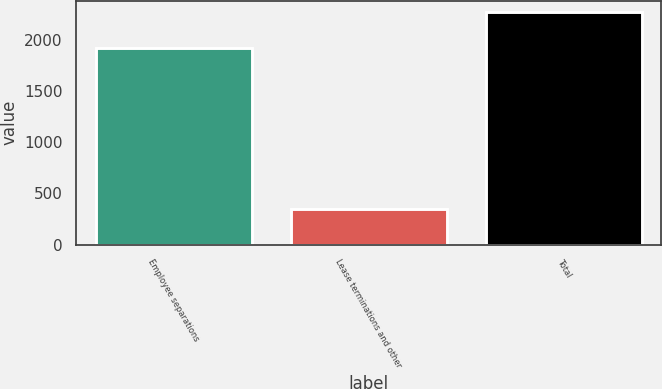Convert chart. <chart><loc_0><loc_0><loc_500><loc_500><bar_chart><fcel>Employee separations<fcel>Lease terminations and other<fcel>Total<nl><fcel>1919<fcel>347<fcel>2266<nl></chart> 